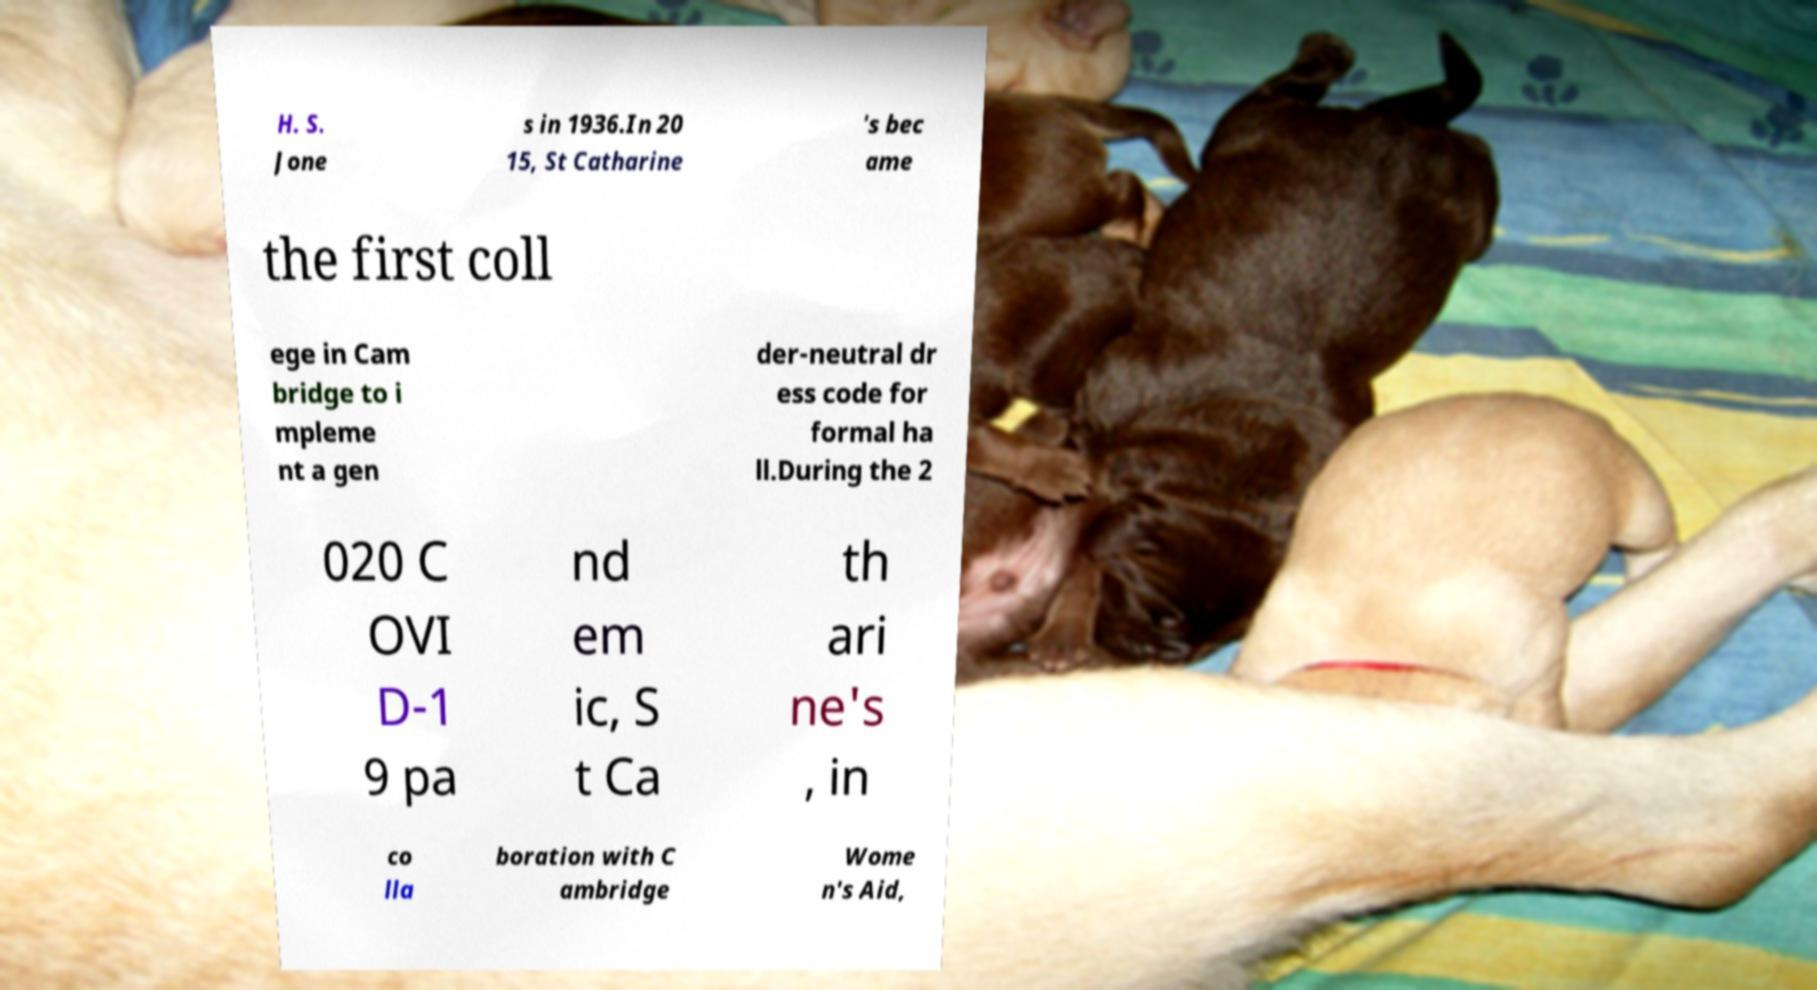For documentation purposes, I need the text within this image transcribed. Could you provide that? H. S. Jone s in 1936.In 20 15, St Catharine 's bec ame the first coll ege in Cam bridge to i mpleme nt a gen der-neutral dr ess code for formal ha ll.During the 2 020 C OVI D-1 9 pa nd em ic, S t Ca th ari ne's , in co lla boration with C ambridge Wome n's Aid, 